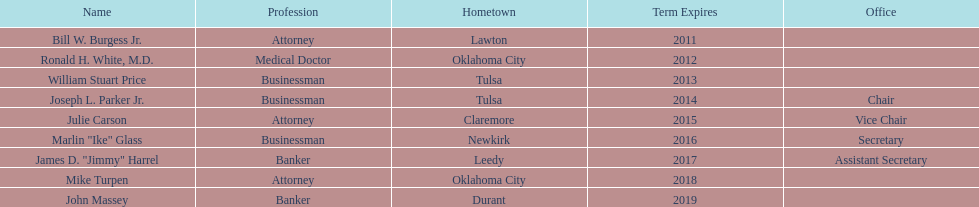Other members of the state regents from tulsa besides joseph l. parker jr. William Stuart Price. 